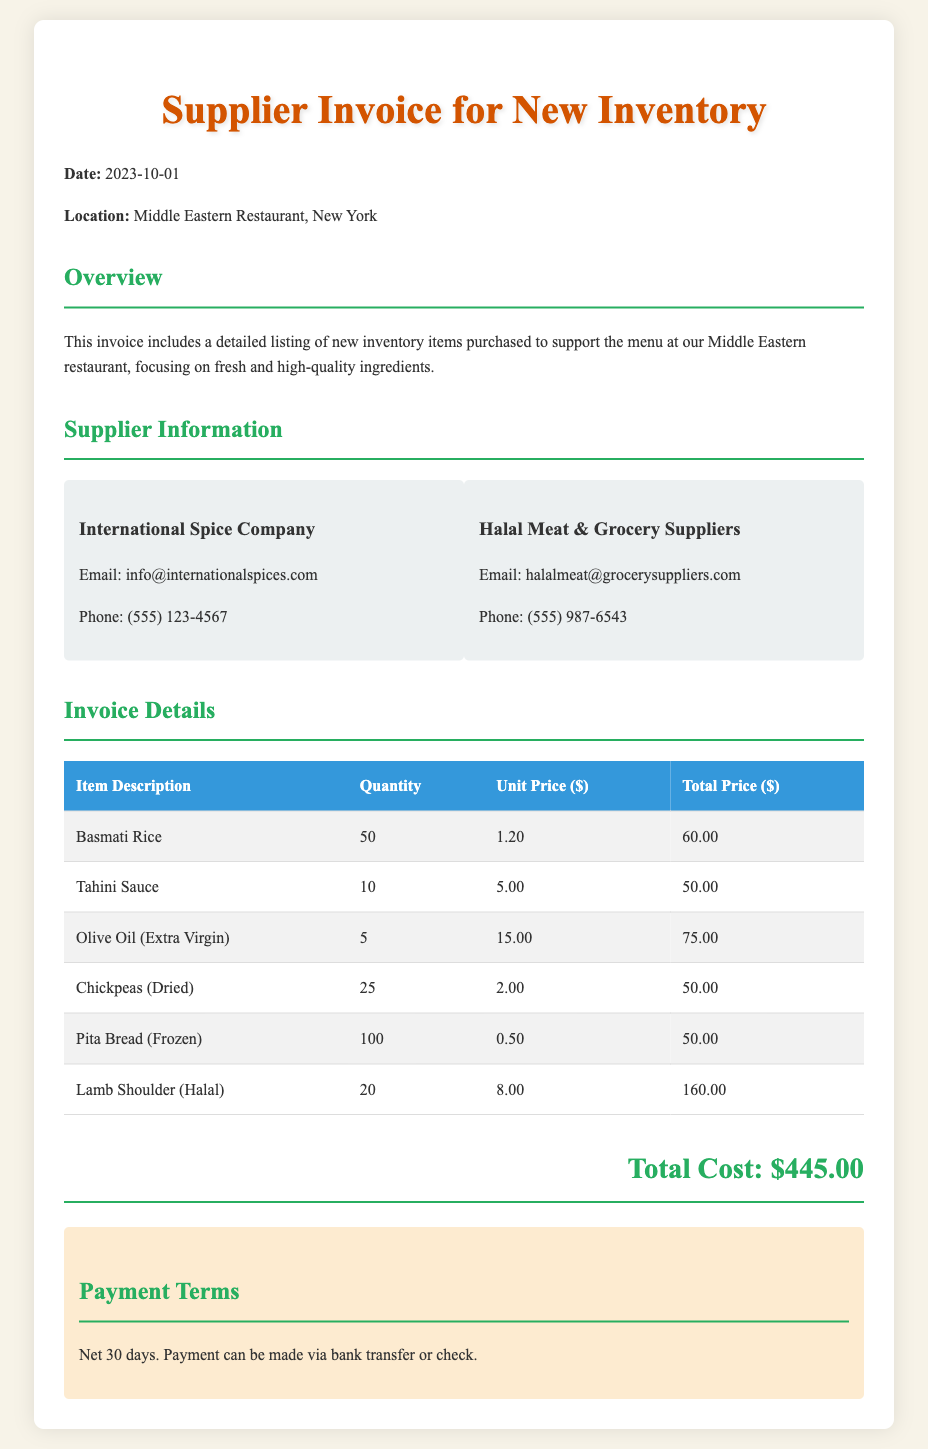What is the date of the invoice? The date of the invoice is referenced clearly in the document.
Answer: 2023-10-01 Who is the supplier of Basmati Rice? The supplier information table provides the names of suppliers; cross-referencing with the item can identify the specific supplier for Basmati Rice.
Answer: International Spice Company How many units of Tahini Sauce were ordered? The invoice details specify the amount of each item listed, including Tahini Sauce.
Answer: 10 What is the unit price of Olive Oil? The table lists each item along with its corresponding unit price.
Answer: 15.00 What is the total cost of the invoice? The total cost is calculated from the summation of all total prices listed in the invoice.
Answer: 445.00 What payment terms are specified in the document? The payment terms section clearly states the conditions for payment in the invoice.
Answer: Net 30 days Which supplier provides Halal meat? The document specifies the name of the supplier dealing with Halal meat goods.
Answer: Halal Meat & Grocery Suppliers How many Pita Breads were ordered? The invoice details include quantities for each ingredient, specifically for Pita Bread.
Answer: 100 What is the total price for Lamb Shoulder? By locating Lamb Shoulder in the invoice details, we can find its total price directly stated.
Answer: 160.00 